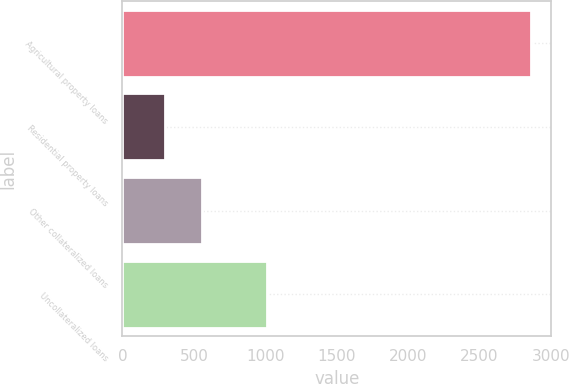Convert chart. <chart><loc_0><loc_0><loc_500><loc_500><bar_chart><fcel>Agricultural property loans<fcel>Residential property loans<fcel>Other collateralized loans<fcel>Uncollateralized loans<nl><fcel>2859<fcel>301<fcel>556.8<fcel>1012<nl></chart> 